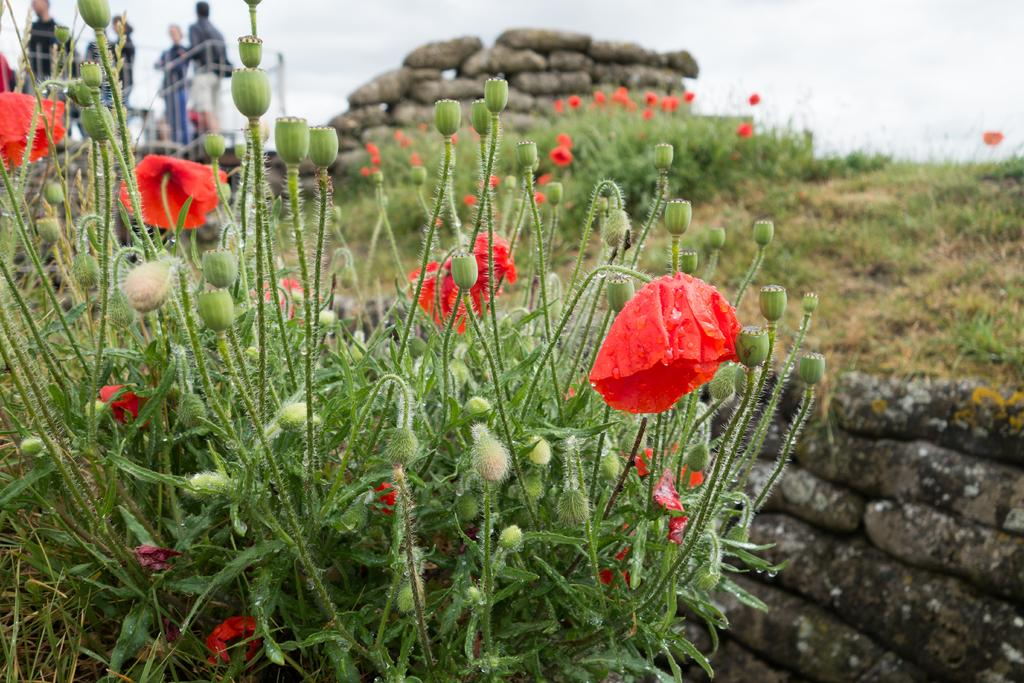What type of plants can be seen in the image? There are plants with flowers and buds in the image. What other objects are present in the image? There are stones and people visible in the image. What is the ground covered with in the image? The ground is covered with grass in the image. What can be seen in the background of the image? The sky is visible in the background of the image. Can you see a mask floating on the river in the image? There is no river or mask present in the image. What type of vessel is being used by the people in the image? The image does not show any vessels being used by the people; they are simply standing or walking. 